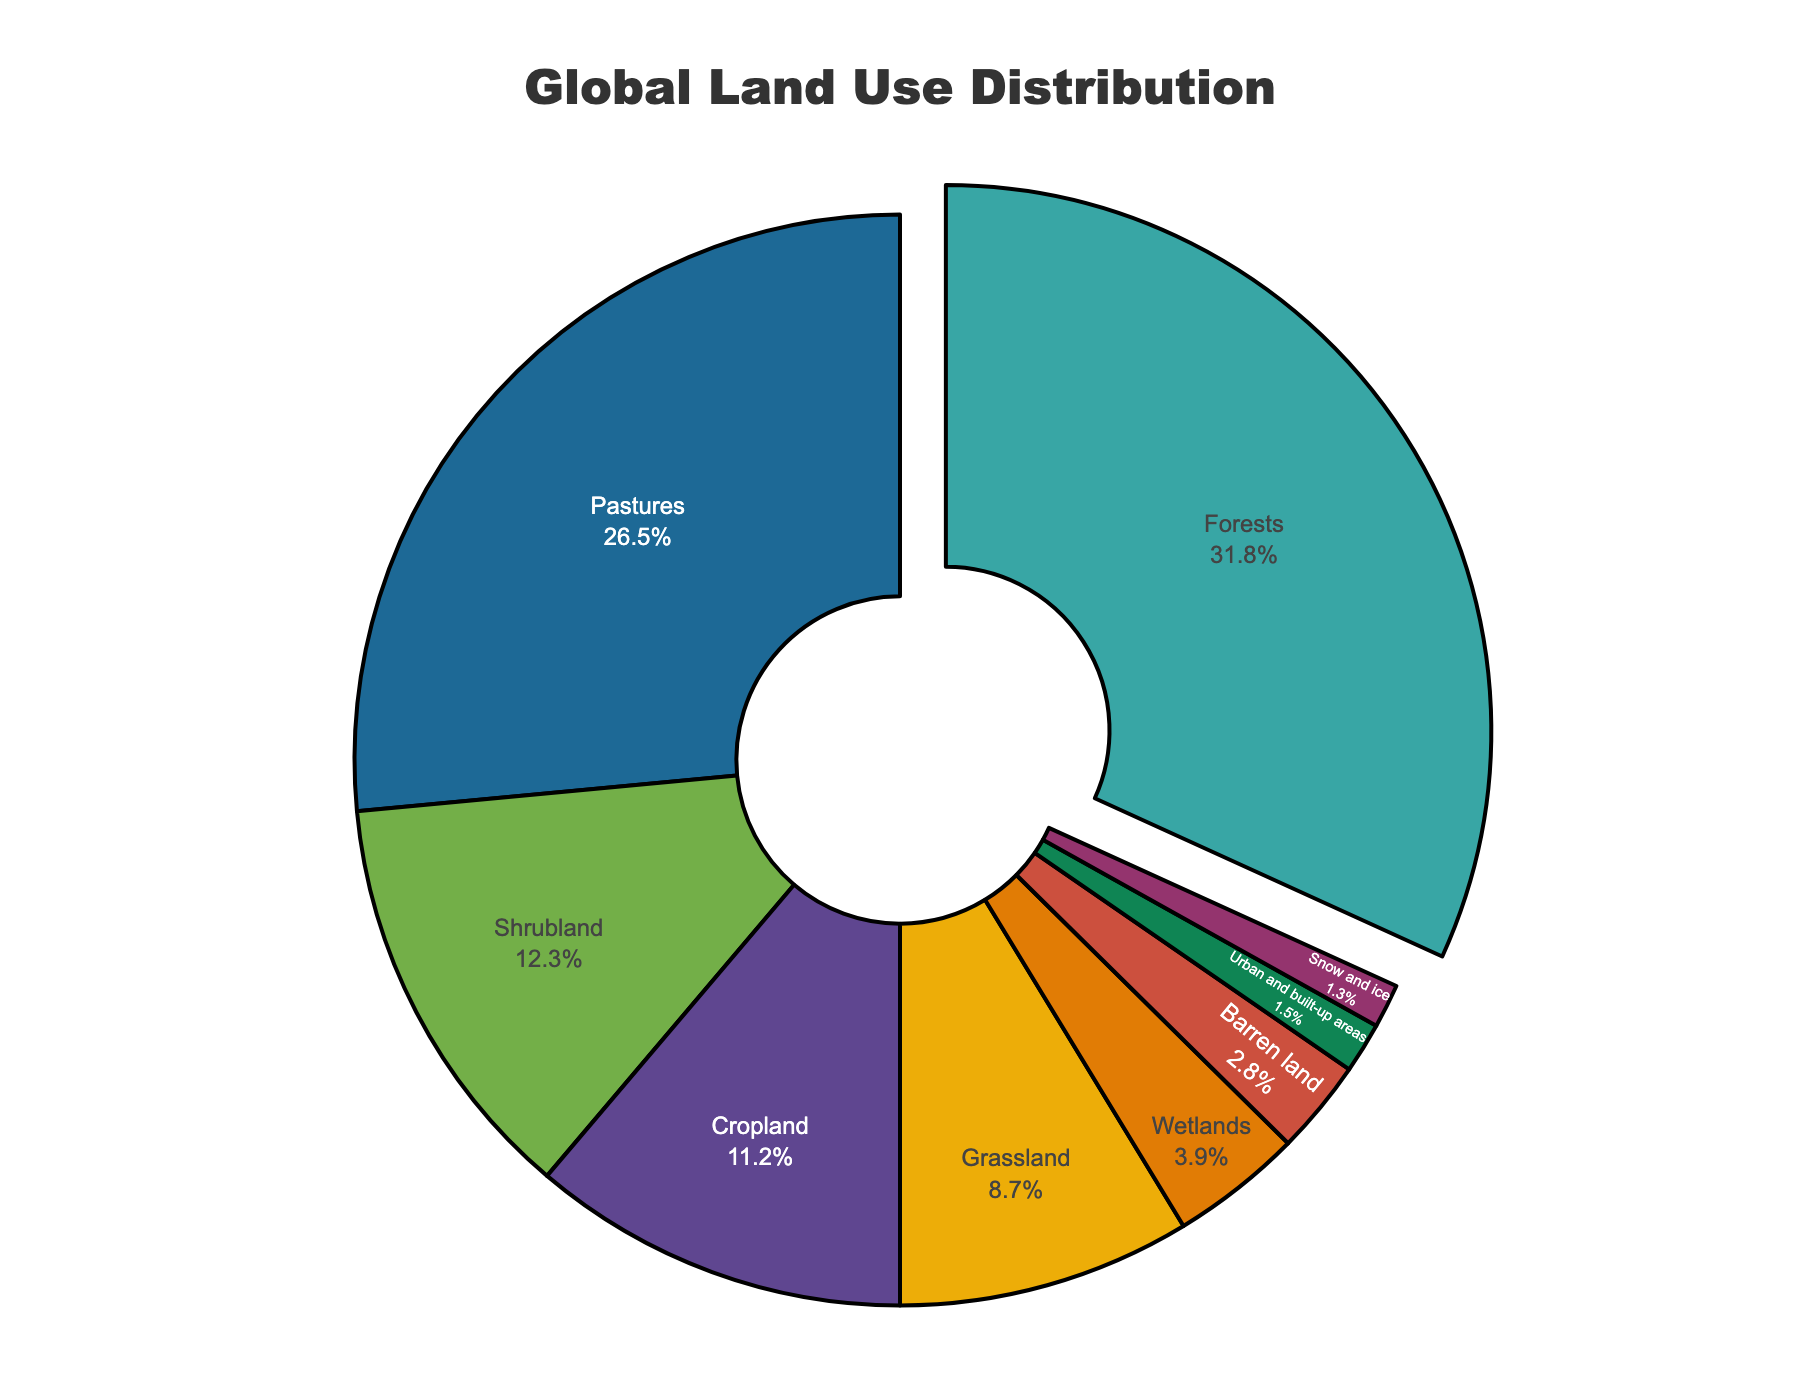What category occupies the largest percentage of global land use? The pie chart predominantly shows the various land uses and their respective percentages. The segment representing 'Forests' is the largest, with a value of 31.8%, making it the largest category in global land use.
Answer: Forests Which two categories combined make up over half of the global land use? To determine which categories together comprise over 50%, we need to add up their percentages. 'Forests' (31.8%) and 'Pastures' (26.5%) together equal 58.3%, surpassing the 50% mark.
Answer: Forests and Pastures Which category occupies the second smallest area in terms of global land use? Observing the pie chart, 'Snow and ice' and 'Urban and built-up areas' appear to be the smallest segments. Among these, 'Urban and built-up areas' is 1.5% and 'Snow and ice' is 1.3%, making 'Urban and built-up areas' the second smallest.
Answer: Urban and built-up areas What is the combined percentage of Shrubland, Grassland, and Wetlands? Sum the percentages of Shrubland (12.3%), Grassland (8.7%), and Wetlands (3.9%): 12.3 + 8.7 + 3.9 = 24.9%.
Answer: 24.9% Is the percentage of Cropland greater than that of Urban and built-up areas? By looking at the pie chart, Cropland accounts for 11.2%, while Urban and built-up areas account for 1.5%. Hence, Cropland has a higher percentage than Urban areas.
Answer: Yes What is the difference in percentage between Barren land and Snow and ice? The percentage for Barren land is 2.8% and for Snow and ice is 1.3%. The difference is calculated as 2.8 - 1.3 = 1.5%.
Answer: 1.5% Which category represents the least on the pie chart, and what percentage does it cover? By closely observing the segments size, 'Snow and ice' is the smallest and it covers 1.3% as reflected in the chart.
Answer: Snow and ice, 1.3% What is the total percentage of all land use categories excluding Forests and Pastures? Subtract the Forests (31.8%) and Pastures (26.5%) from the total percentage (100%). The calculation: 100 - 31.8 - 26.5 = 41.7%.
Answer: 41.7% If you combined the percentages of the three smallest categories, what percentage would you get? Identify the three smallest categories: 'Snow and ice' (1.3%), 'Urban and built-up areas' (1.5%), and 'Barren land' (2.8%). Adding them: 1.3 + 1.5 + 2.8 = 5.6%.
Answer: 5.6% Which category is highlighted by being pulled out in the chart and why? The section representing 'Forests' is being pulled out, as it has the highest percentage among all categories (31.8%).
Answer: Forests 